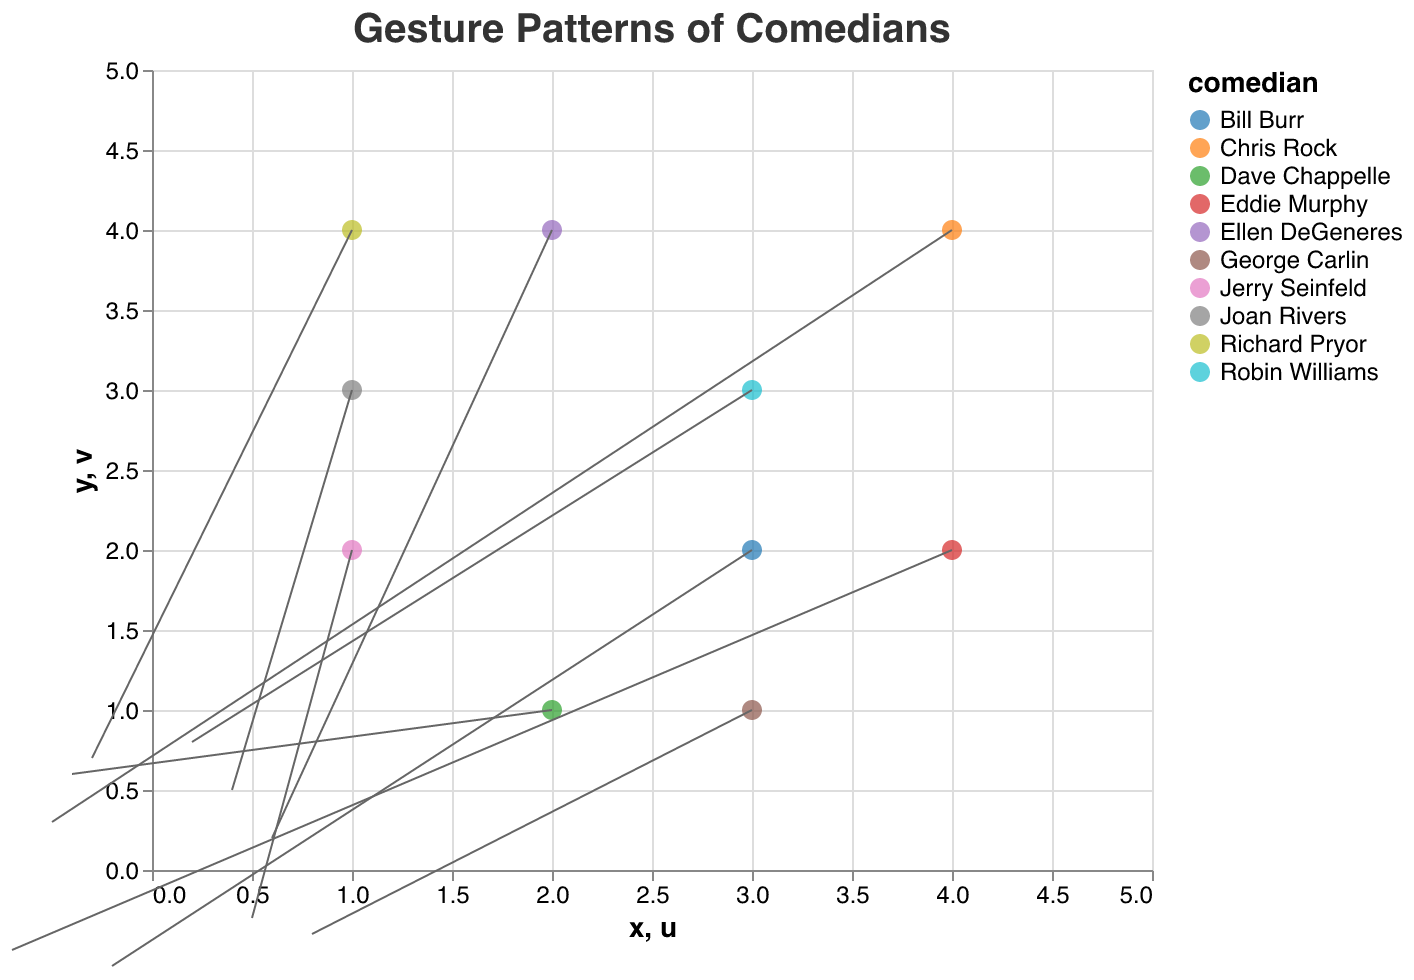How many comedians have gesture patterns starting at coordinate (2, 1)? Refer to the figure and identify the starting coordinates matching (2, 1). Only Dave Chappelle's gesture pattern starts at this coordinate.
Answer: 1 Which comedian's gesture pattern starts at (3, 3) and moves primarily upwards? Locate the coordinate (3, 3) and observe the direction of the gesture movement. Robin Williams's gesture pattern starts at (3, 3) and moves upwards with a positive y-component (0.8).
Answer: Robin Williams Compare the gestures of Jerry Seinfeld and Eddie Murphy. Whose gestures involve a larger movement in the x-direction? Check the horizontal components of gestures (u) for both comedians. Jerry Seinfeld has u=0.5 and Eddie Murphy has u=-0.7.
Answer: Jerry Seinfeld Which gesture pattern moves downwards most significantly? Observe the y-components (v) of all gestures to determine the most negative value. Eddie Murphy's v=-0.5 is the most negative.
Answer: Eddie Murphy How many comedians' gestures start from point (1, 4) and point (1, 3)? Identify the initial coordinates (1, 4) and (1, 3) in the plot. Richard Pryor starts at (1, 4) and Joan Rivers starts at (1, 3).
Answer: 2 Which comedian's gesture has the largest positive horizontal component? Look at the u values for all comedians to determine the largest positive value. George Carlin's gesture with u=0.8 is the largest.
Answer: George Carlin Is there any comedian whose gesture appears to move diagonally downwards starting from coordinate (2, 1)? Check the direction of gestures starting from (2, 1) to see if both x and y components are negative. Dave Chappelle's gesture has a positive y-component, thus not a downward movement.
Answer: No If you sum the x-components of George Carlin and Bill Burr, do they result in a positive or negative value? Add the x-components: 0.8 (George Carlin) and -0.2 (Bill Burr). The sum is positive.
Answer: Positive Find the comedian whose gesture moves vertically downwards the most. Observe the y-components of each comedian's gesture, focusing on the most negative value. Eddie Murphy has the largest negative y-component of -0.5.
Answer: Eddie Murphy 